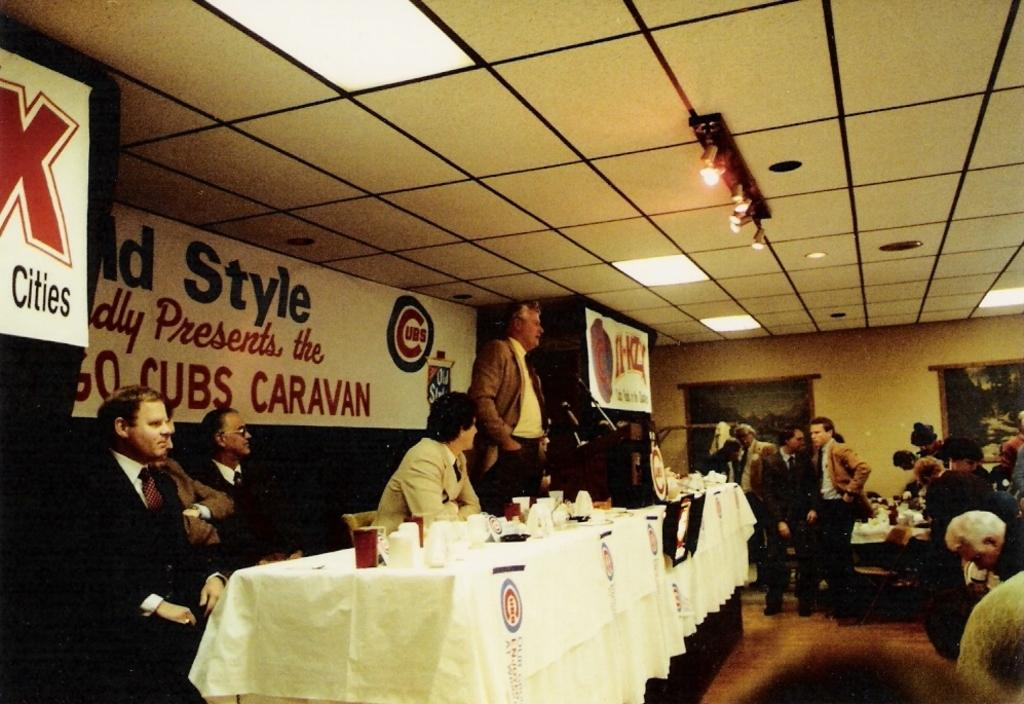What type of objects are on the table in the image? There are cups and other objects on the table in the image. Can you describe the background of the image? There is a banner in the background of the image. What is visible on top in the image? Lights are visible on top in the image. What type of glass is the spy using to observe the scene in the image? There is no glass or spy present in the image. 